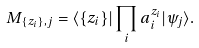<formula> <loc_0><loc_0><loc_500><loc_500>M _ { \{ z _ { i } \} , j } = \langle \{ z _ { i } \} | \prod _ { i } a _ { i } ^ { z _ { i } } | \psi _ { j } \rangle .</formula> 